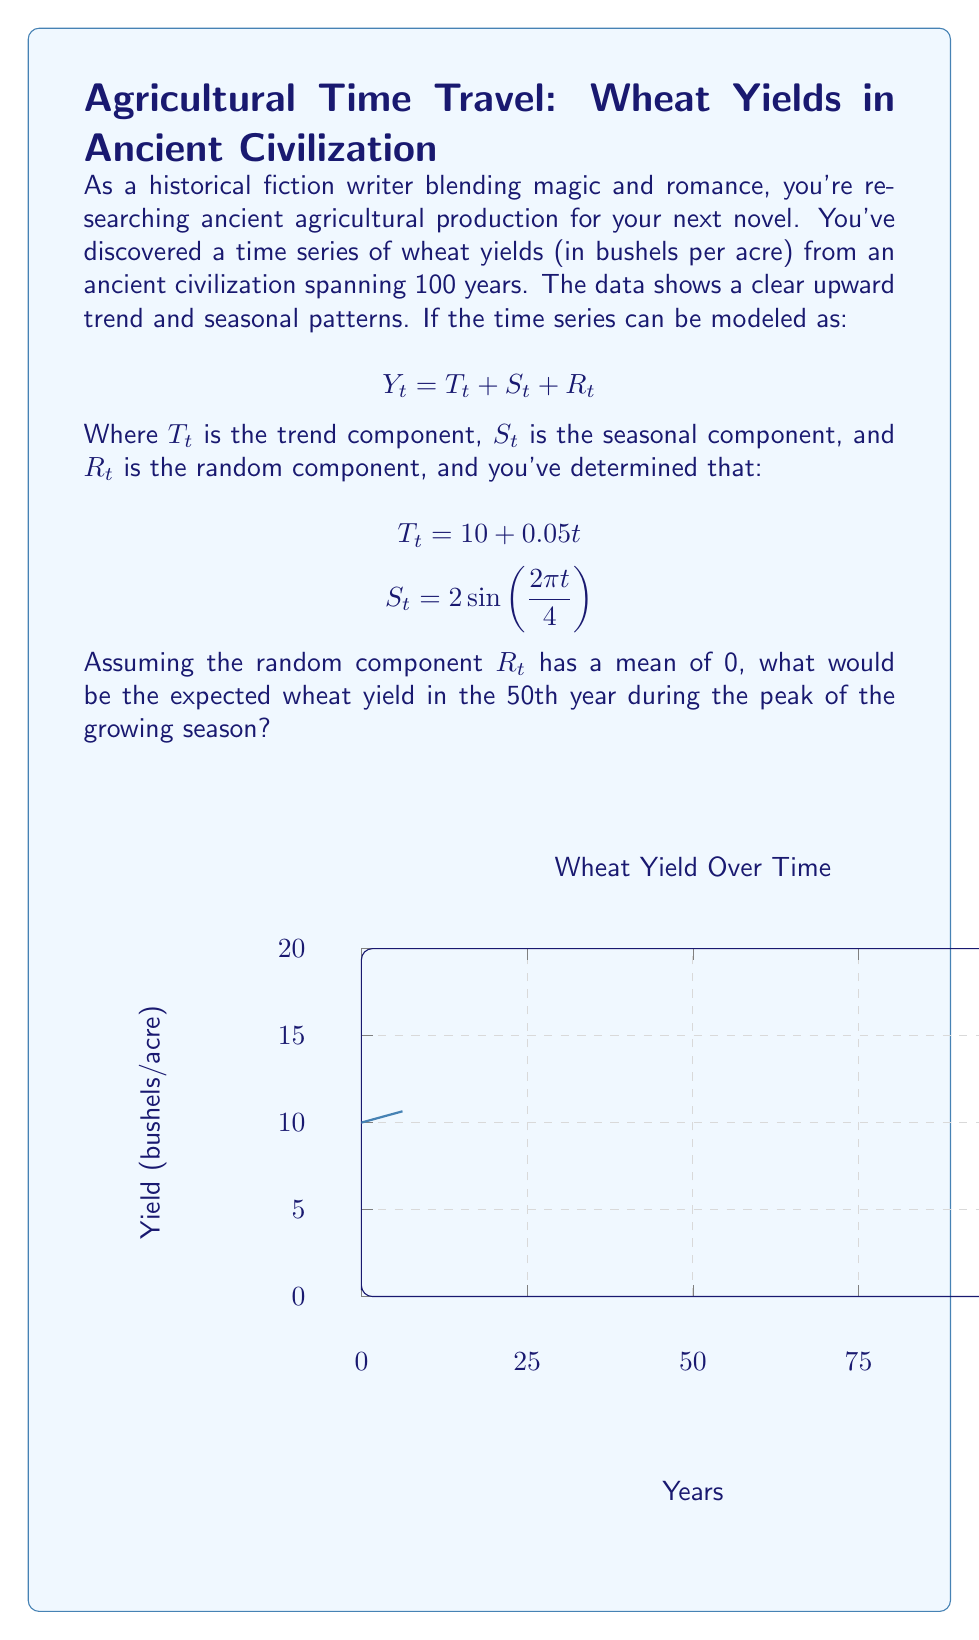Show me your answer to this math problem. Let's approach this step-by-step:

1) We're given the time series model: $Y_t = T_t + S_t + R_t$

2) The trend component is: $T_t = 10 + 0.05t$
   For the 50th year, $t = 50$, so:
   $T_{50} = 10 + 0.05(50) = 10 + 2.5 = 12.5$

3) The seasonal component is: $S_t = 2\sin(\frac{2\pi t}{4})$
   The peak of the growing season would occur when this sine function is at its maximum, which is when $\sin(\frac{2\pi t}{4}) = 1$
   So, at the peak, $S_t = 2(1) = 2$

4) The random component $R_t$ has a mean of 0, so for the expected yield, we can ignore this term.

5) Therefore, the expected yield $Y_{50}$ at the peak of the growing season in the 50th year is:

   $Y_{50} = T_{50} + S_{peak} + E[R_t]$
   $Y_{50} = 12.5 + 2 + 0 = 14.5$
Answer: 14.5 bushels per acre 